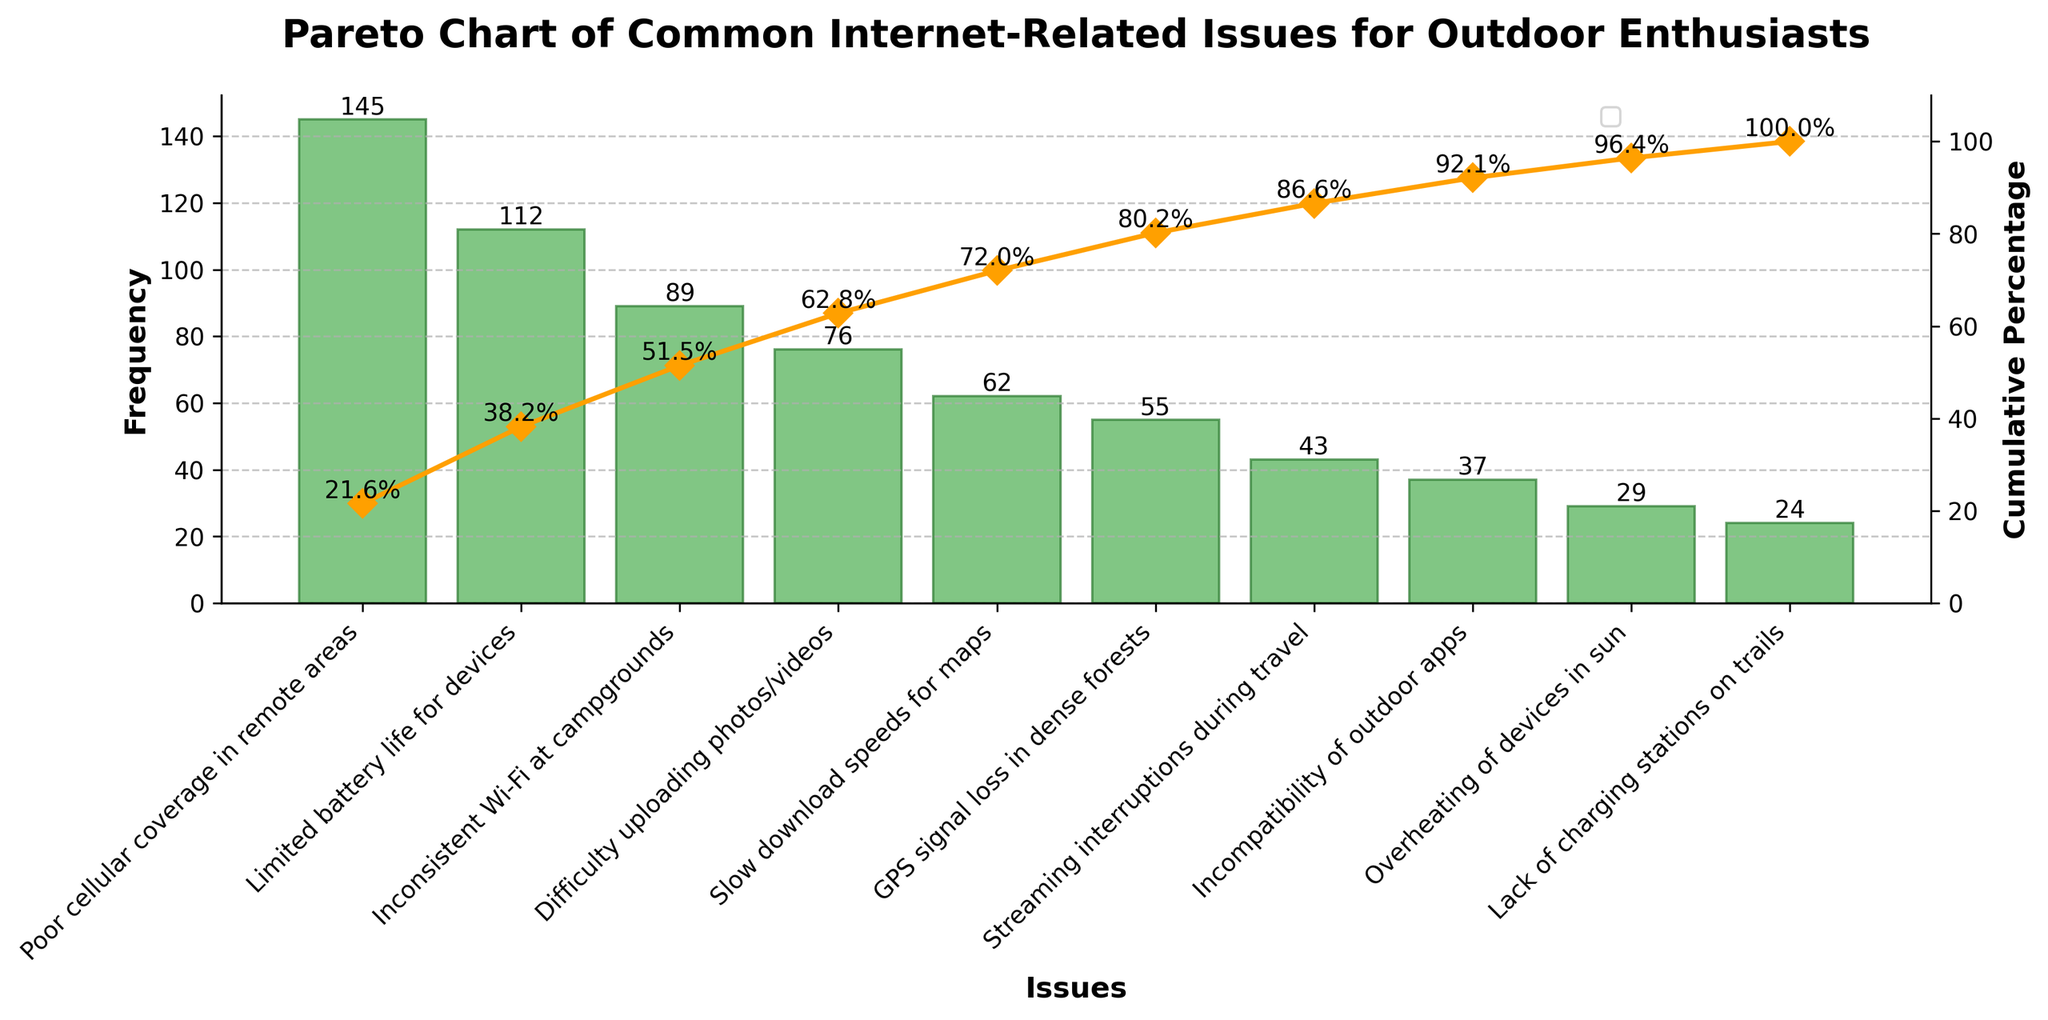What is the most common internet-related issue experienced by outdoor enthusiasts? The leftmost bar in the Pareto chart represents the most common issue, which has the highest frequency.
Answer: Poor cellular coverage in remote areas What is the total frequency of the top three issues combined? The top three issues are Poor cellular coverage in remote areas (145), Limited battery life for devices (112), and Inconsistent Wi-Fi at campgrounds (89). Adding these up: 145 + 112 + 89 = 346.
Answer: 346 What percentage of issues does the most common issue represent? The most common issue is Poor cellular coverage in remote areas with a frequency of 145. The total frequency for all issues combined is 672. The percentage is (145 / 672) * 100 ≈ 21.6%.
Answer: 21.6% How many issues have a frequency greater than 50? By looking at the frequencies for each issue on the plot, those greater than 50 are Poor cellular coverage in remote areas (145), Limited battery life for devices (112), Inconsistent Wi-Fi at campgrounds (89), Difficulty uploading photos/videos (76), and Slow download speeds for maps (62). There are 5 such issues.
Answer: 5 Which issue has the lowest frequency and what is it? The rightmost bar in the Pareto chart represents the issue with the lowest frequency, which is Lack of charging stations on trails with a frequency of 24.
Answer: Lack of charging stations on trails What is the cumulative percentage after the top five issues? The cumulative percentages shown on the chart for the top five issues are approximately (21.6%, 38.3%, 51.6%, 62.9%, and 72.1%). The cumulative percentage after the top five issues is 72.1%.
Answer: 72.1% How do the frequencies of Incompatibility of outdoor apps and Overheating of devices in sun compare? The respective frequencies shown on the chart are 37 for Incompatibility of outdoor apps and 29 for Overheating of devices in sun. Incompatibility of outdoor apps has a greater frequency.
Answer: Incompatibility of outdoor apps What is the cumulative percentage difference between GPS signal loss in dense forests and Streaming interruptions during travel? The cumulative percentages for these issues are approximately 60.8% for GPS signal loss in dense forests and 67.2% for Streaming interruptions during travel. The difference is 67.2% - 60.8% ≈ 6.4%.
Answer: 6.4% What is the frequency range of all the issues? The highest frequency is 145 for Poor cellular coverage in remote areas and the lowest frequency is 24 for Lack of charging stations on trails. The frequency range is 145 - 24 = 121.
Answer: 121 